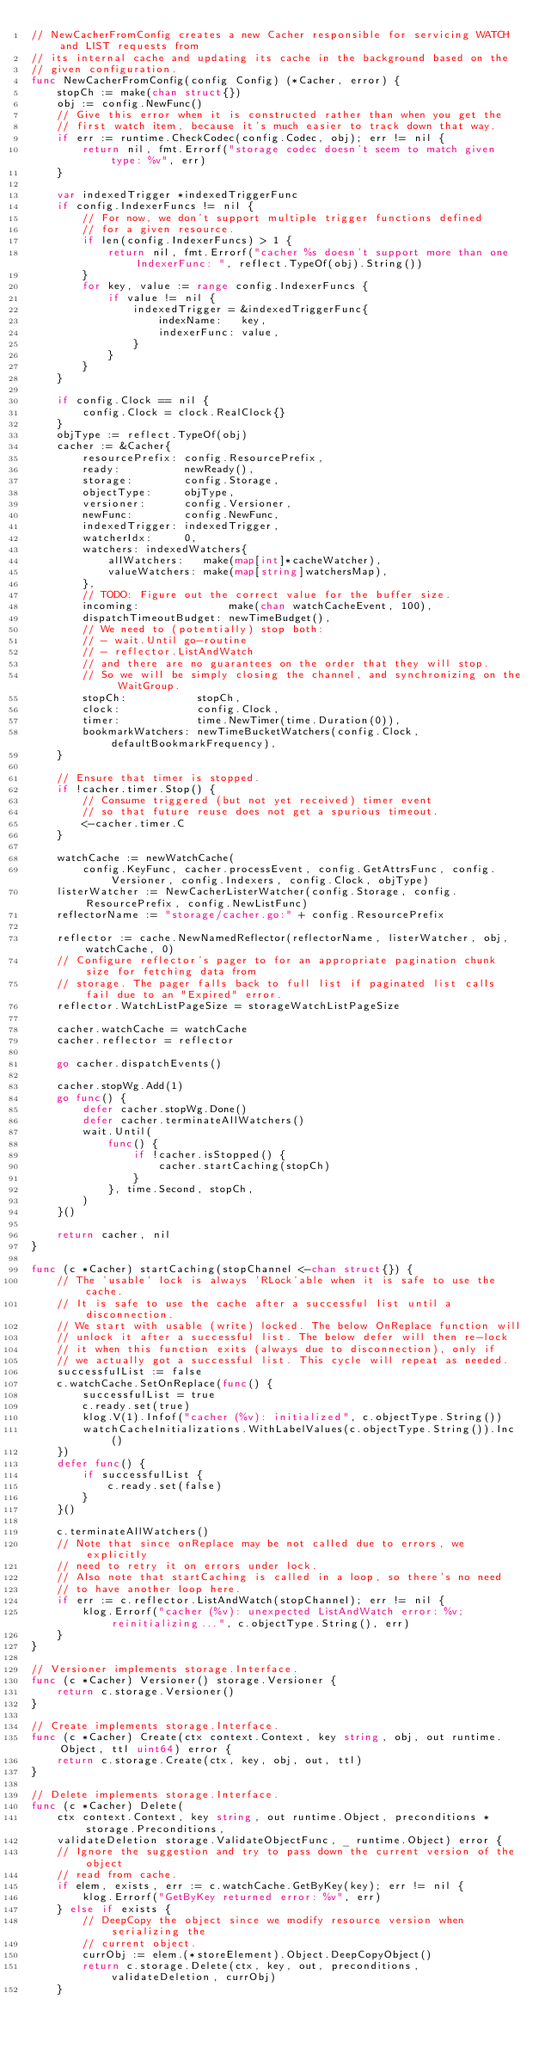<code> <loc_0><loc_0><loc_500><loc_500><_Go_>// NewCacherFromConfig creates a new Cacher responsible for servicing WATCH and LIST requests from
// its internal cache and updating its cache in the background based on the
// given configuration.
func NewCacherFromConfig(config Config) (*Cacher, error) {
	stopCh := make(chan struct{})
	obj := config.NewFunc()
	// Give this error when it is constructed rather than when you get the
	// first watch item, because it's much easier to track down that way.
	if err := runtime.CheckCodec(config.Codec, obj); err != nil {
		return nil, fmt.Errorf("storage codec doesn't seem to match given type: %v", err)
	}

	var indexedTrigger *indexedTriggerFunc
	if config.IndexerFuncs != nil {
		// For now, we don't support multiple trigger functions defined
		// for a given resource.
		if len(config.IndexerFuncs) > 1 {
			return nil, fmt.Errorf("cacher %s doesn't support more than one IndexerFunc: ", reflect.TypeOf(obj).String())
		}
		for key, value := range config.IndexerFuncs {
			if value != nil {
				indexedTrigger = &indexedTriggerFunc{
					indexName:   key,
					indexerFunc: value,
				}
			}
		}
	}

	if config.Clock == nil {
		config.Clock = clock.RealClock{}
	}
	objType := reflect.TypeOf(obj)
	cacher := &Cacher{
		resourcePrefix: config.ResourcePrefix,
		ready:          newReady(),
		storage:        config.Storage,
		objectType:     objType,
		versioner:      config.Versioner,
		newFunc:        config.NewFunc,
		indexedTrigger: indexedTrigger,
		watcherIdx:     0,
		watchers: indexedWatchers{
			allWatchers:   make(map[int]*cacheWatcher),
			valueWatchers: make(map[string]watchersMap),
		},
		// TODO: Figure out the correct value for the buffer size.
		incoming:              make(chan watchCacheEvent, 100),
		dispatchTimeoutBudget: newTimeBudget(),
		// We need to (potentially) stop both:
		// - wait.Until go-routine
		// - reflector.ListAndWatch
		// and there are no guarantees on the order that they will stop.
		// So we will be simply closing the channel, and synchronizing on the WaitGroup.
		stopCh:           stopCh,
		clock:            config.Clock,
		timer:            time.NewTimer(time.Duration(0)),
		bookmarkWatchers: newTimeBucketWatchers(config.Clock, defaultBookmarkFrequency),
	}

	// Ensure that timer is stopped.
	if !cacher.timer.Stop() {
		// Consume triggered (but not yet received) timer event
		// so that future reuse does not get a spurious timeout.
		<-cacher.timer.C
	}

	watchCache := newWatchCache(
		config.KeyFunc, cacher.processEvent, config.GetAttrsFunc, config.Versioner, config.Indexers, config.Clock, objType)
	listerWatcher := NewCacherListerWatcher(config.Storage, config.ResourcePrefix, config.NewListFunc)
	reflectorName := "storage/cacher.go:" + config.ResourcePrefix

	reflector := cache.NewNamedReflector(reflectorName, listerWatcher, obj, watchCache, 0)
	// Configure reflector's pager to for an appropriate pagination chunk size for fetching data from
	// storage. The pager falls back to full list if paginated list calls fail due to an "Expired" error.
	reflector.WatchListPageSize = storageWatchListPageSize

	cacher.watchCache = watchCache
	cacher.reflector = reflector

	go cacher.dispatchEvents()

	cacher.stopWg.Add(1)
	go func() {
		defer cacher.stopWg.Done()
		defer cacher.terminateAllWatchers()
		wait.Until(
			func() {
				if !cacher.isStopped() {
					cacher.startCaching(stopCh)
				}
			}, time.Second, stopCh,
		)
	}()

	return cacher, nil
}

func (c *Cacher) startCaching(stopChannel <-chan struct{}) {
	// The 'usable' lock is always 'RLock'able when it is safe to use the cache.
	// It is safe to use the cache after a successful list until a disconnection.
	// We start with usable (write) locked. The below OnReplace function will
	// unlock it after a successful list. The below defer will then re-lock
	// it when this function exits (always due to disconnection), only if
	// we actually got a successful list. This cycle will repeat as needed.
	successfulList := false
	c.watchCache.SetOnReplace(func() {
		successfulList = true
		c.ready.set(true)
		klog.V(1).Infof("cacher (%v): initialized", c.objectType.String())
		watchCacheInitializations.WithLabelValues(c.objectType.String()).Inc()
	})
	defer func() {
		if successfulList {
			c.ready.set(false)
		}
	}()

	c.terminateAllWatchers()
	// Note that since onReplace may be not called due to errors, we explicitly
	// need to retry it on errors under lock.
	// Also note that startCaching is called in a loop, so there's no need
	// to have another loop here.
	if err := c.reflector.ListAndWatch(stopChannel); err != nil {
		klog.Errorf("cacher (%v): unexpected ListAndWatch error: %v; reinitializing...", c.objectType.String(), err)
	}
}

// Versioner implements storage.Interface.
func (c *Cacher) Versioner() storage.Versioner {
	return c.storage.Versioner()
}

// Create implements storage.Interface.
func (c *Cacher) Create(ctx context.Context, key string, obj, out runtime.Object, ttl uint64) error {
	return c.storage.Create(ctx, key, obj, out, ttl)
}

// Delete implements storage.Interface.
func (c *Cacher) Delete(
	ctx context.Context, key string, out runtime.Object, preconditions *storage.Preconditions,
	validateDeletion storage.ValidateObjectFunc, _ runtime.Object) error {
	// Ignore the suggestion and try to pass down the current version of the object
	// read from cache.
	if elem, exists, err := c.watchCache.GetByKey(key); err != nil {
		klog.Errorf("GetByKey returned error: %v", err)
	} else if exists {
		// DeepCopy the object since we modify resource version when serializing the
		// current object.
		currObj := elem.(*storeElement).Object.DeepCopyObject()
		return c.storage.Delete(ctx, key, out, preconditions, validateDeletion, currObj)
	}</code> 